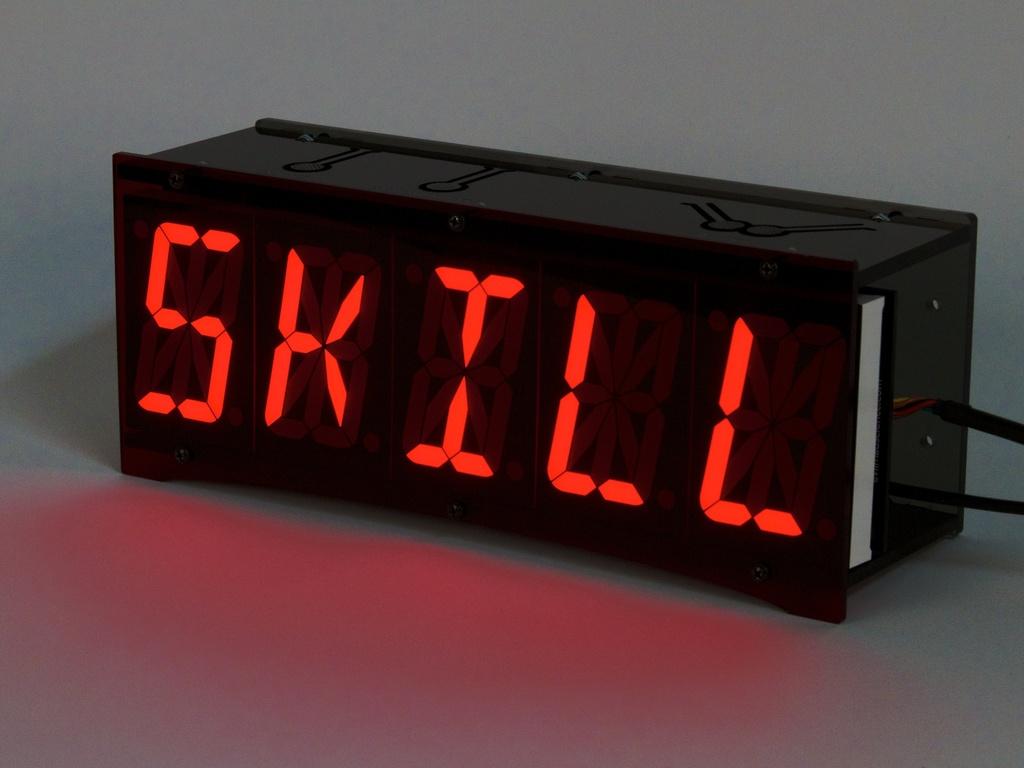Is this a clock or something else?
Give a very brief answer. Something else. 